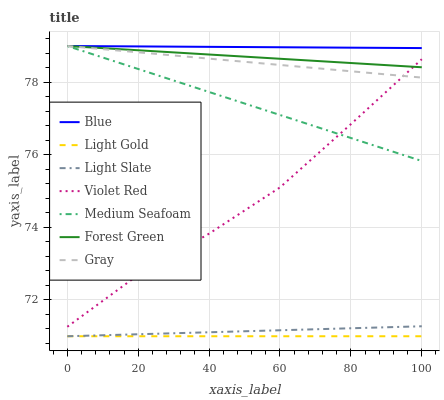Does Light Gold have the minimum area under the curve?
Answer yes or no. Yes. Does Blue have the maximum area under the curve?
Answer yes or no. Yes. Does Gray have the minimum area under the curve?
Answer yes or no. No. Does Gray have the maximum area under the curve?
Answer yes or no. No. Is Light Gold the smoothest?
Answer yes or no. Yes. Is Violet Red the roughest?
Answer yes or no. Yes. Is Gray the smoothest?
Answer yes or no. No. Is Gray the roughest?
Answer yes or no. No. Does Light Slate have the lowest value?
Answer yes or no. Yes. Does Gray have the lowest value?
Answer yes or no. No. Does Medium Seafoam have the highest value?
Answer yes or no. Yes. Does Violet Red have the highest value?
Answer yes or no. No. Is Light Gold less than Forest Green?
Answer yes or no. Yes. Is Forest Green greater than Light Gold?
Answer yes or no. Yes. Does Forest Green intersect Blue?
Answer yes or no. Yes. Is Forest Green less than Blue?
Answer yes or no. No. Is Forest Green greater than Blue?
Answer yes or no. No. Does Light Gold intersect Forest Green?
Answer yes or no. No. 